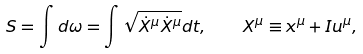<formula> <loc_0><loc_0><loc_500><loc_500>S = \int d \omega = \int \sqrt { \dot { X } ^ { \mu } \dot { X } ^ { \mu } } d t , \quad X ^ { \mu } \equiv x ^ { \mu } + I u ^ { \mu } ,</formula> 